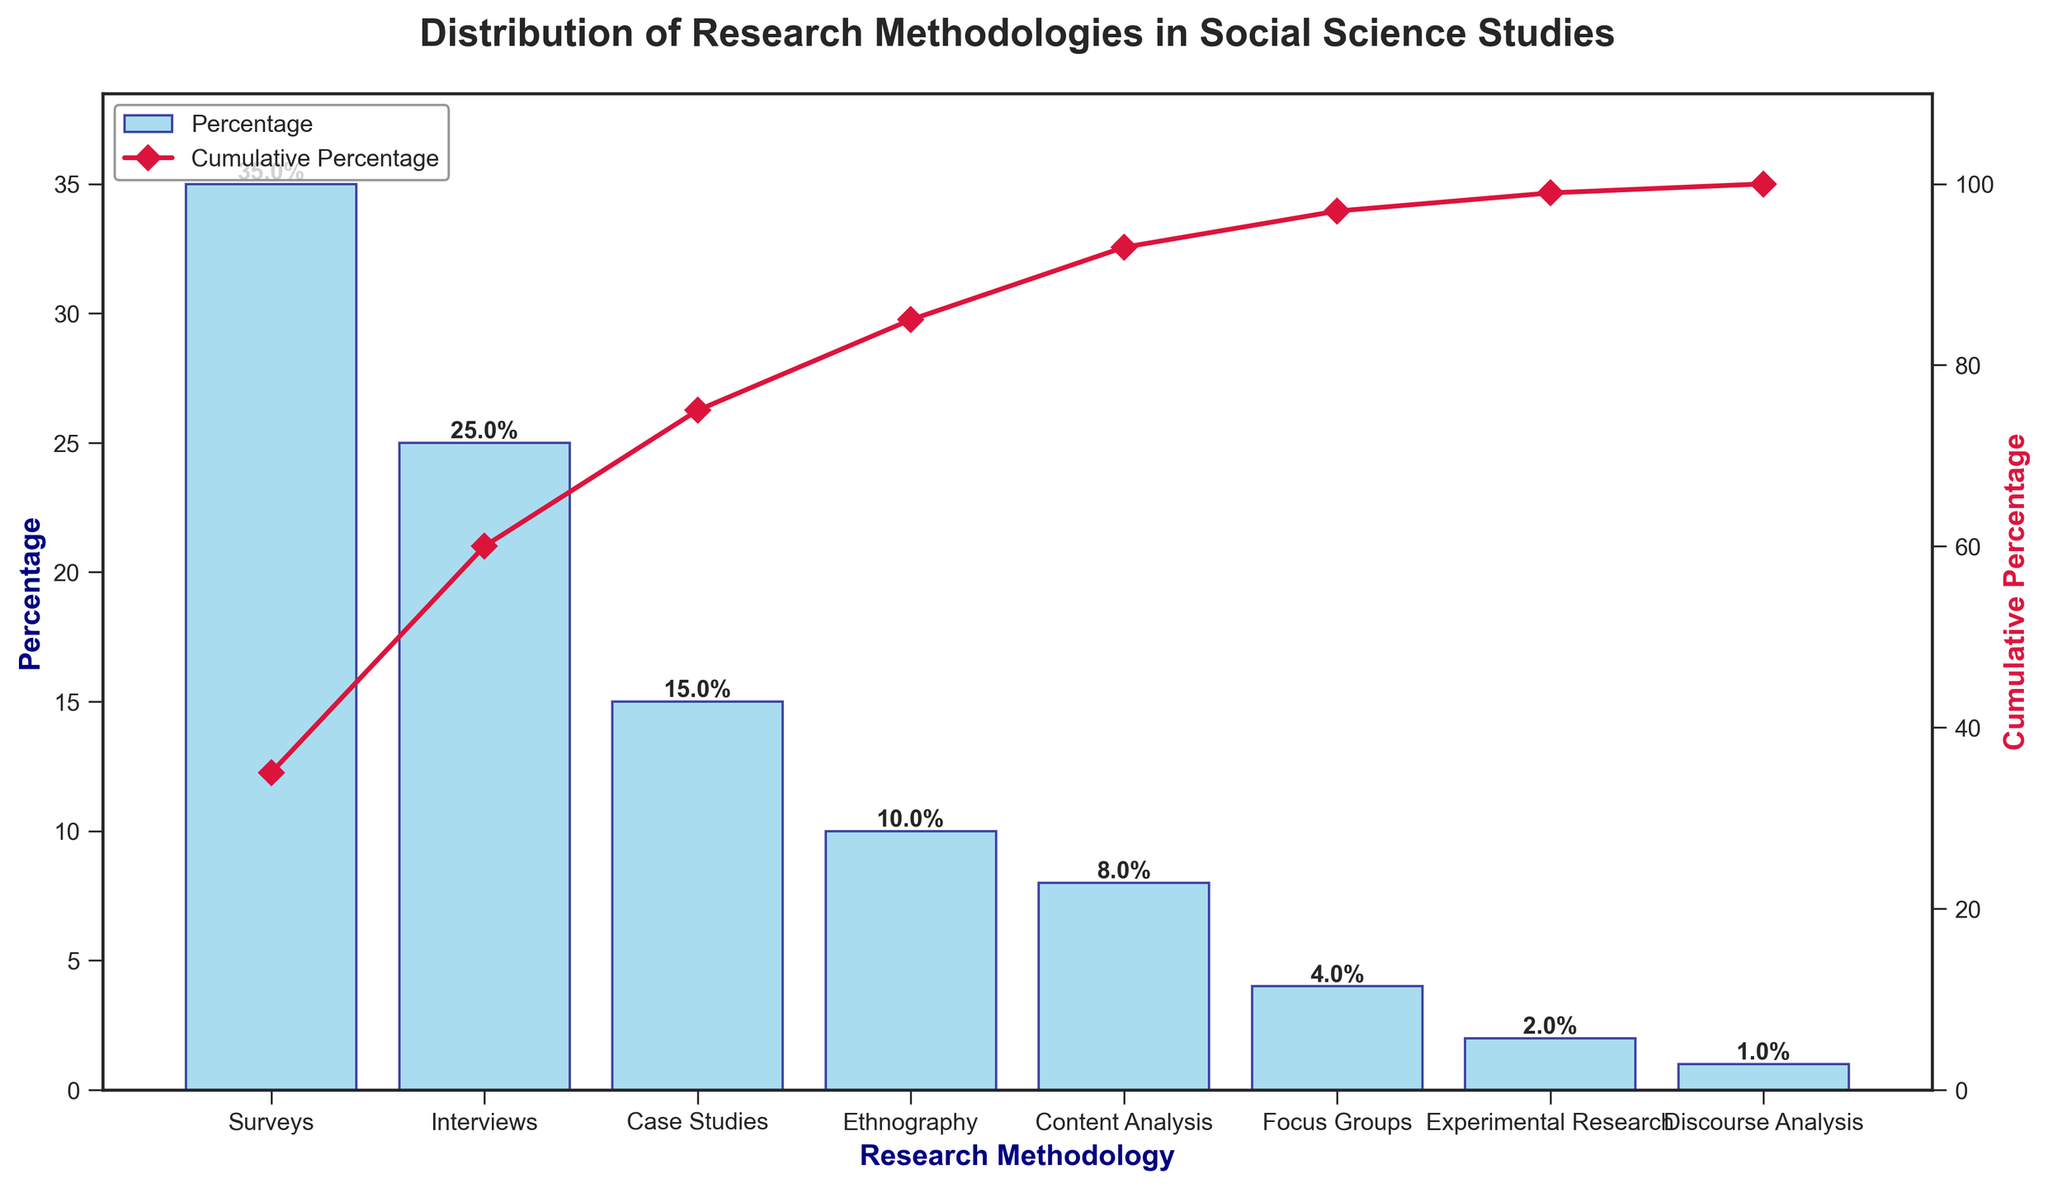What is the title of the chart? The title is located at the top of the chart. It summarizes the content of the chart, indicating the subject matter the data represents.
Answer: Distribution of Research Methodologies in Social Science Studies Which research methodology is most frequently employed according to the chart? By examining the bars, the tallest one indicates the most frequently employed methodology.
Answer: Surveys What percentage of studies use Interviews as their research methodology? Look for the bar labeled "Interviews" and read the percentage value at the top or by referring to the y-axis.
Answer: 25% How many research methodologies account for 50% of the total distribution? Follow the cumulative percentage line until it reaches 50% and count the number of methodologies below this point.
Answer: Two (Surveys and Interviews) What is the percentage difference between the usage of Case Studies and Focus Groups? Refer to the individual bar heights or percentage labels for both methodologies, then subtract the smaller percentage from the larger one.
Answer: 15% - 4% = 11% By how much does Ethnography's percentage exceed that of Experimental Research? Find the bars for "Ethnography" and "Experimental Research," then subtract the percentage of Experimental Research from Ethnography's percentage.
Answer: 10% - 2% = 8% List the research methodologies that make up at least 75% of the total distribution. Follow the cumulative percentage line until it reaches approximately 75% and list the methodologies up to that point.
Answer: Surveys, Interviews, Case Studies, Ethnography Which research methodology has the least percentage of use? Identify the shortest bar or the one labeled with the smallest percentage.
Answer: Discourse Analysis What is the cumulative percentage for the first three methodologies? Add the percentages for Surveys, Interviews, and Case Studies to find their combined effect.
Answer: 35% + 25% + 15% = 75% Describe the appearance of the cumulative percentage line on the chart. The cumulative percentage line is drawn from the left to the right across the plot, beginning at the first methodology. It is colored differently, uses markers to indicate data points, and shows an increasing trend as methodologies are added.
Answer: The cumulative percentage line is crimson in color with diamond markers and shows an increasing trend 